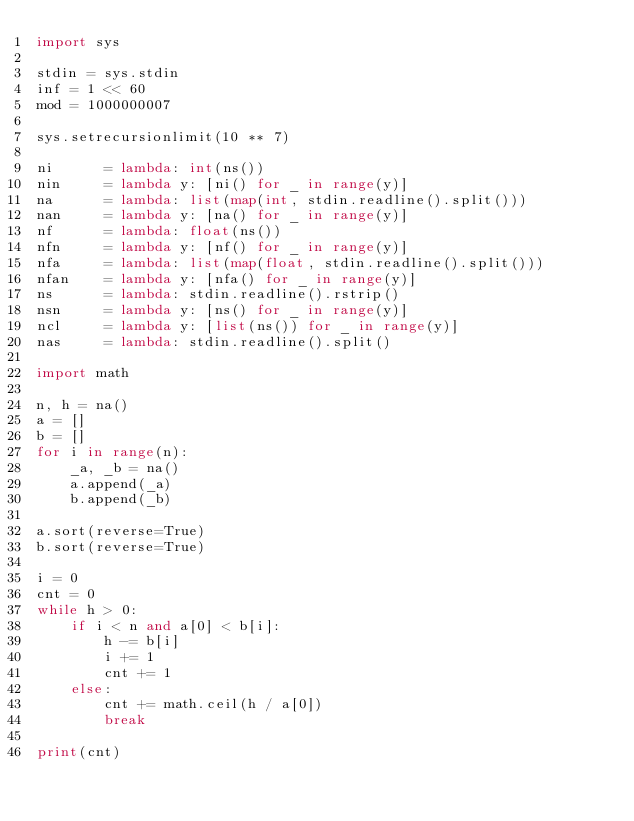Convert code to text. <code><loc_0><loc_0><loc_500><loc_500><_Python_>import sys

stdin = sys.stdin
inf = 1 << 60
mod = 1000000007

sys.setrecursionlimit(10 ** 7)

ni      = lambda: int(ns())
nin     = lambda y: [ni() for _ in range(y)]
na      = lambda: list(map(int, stdin.readline().split()))
nan     = lambda y: [na() for _ in range(y)]
nf      = lambda: float(ns())
nfn     = lambda y: [nf() for _ in range(y)]
nfa     = lambda: list(map(float, stdin.readline().split()))
nfan    = lambda y: [nfa() for _ in range(y)]
ns      = lambda: stdin.readline().rstrip()
nsn     = lambda y: [ns() for _ in range(y)]
ncl     = lambda y: [list(ns()) for _ in range(y)]
nas     = lambda: stdin.readline().split()

import math

n, h = na()
a = []
b = []
for i in range(n):
    _a, _b = na()
    a.append(_a)
    b.append(_b)

a.sort(reverse=True)
b.sort(reverse=True)

i = 0
cnt = 0
while h > 0:
    if i < n and a[0] < b[i]:
        h -= b[i]
        i += 1
        cnt += 1
    else:
        cnt += math.ceil(h / a[0])
        break

print(cnt)</code> 